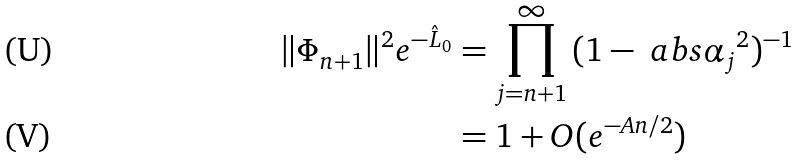<formula> <loc_0><loc_0><loc_500><loc_500>\| \Phi _ { n + 1 } \| ^ { 2 } e ^ { - \hat { L } _ { 0 } } & = \prod _ { j = n + 1 } ^ { \infty } \, ( 1 - \ a b s { \alpha _ { j } } ^ { 2 } ) ^ { - 1 } \\ & = 1 + O ( e ^ { - A n / 2 } )</formula> 